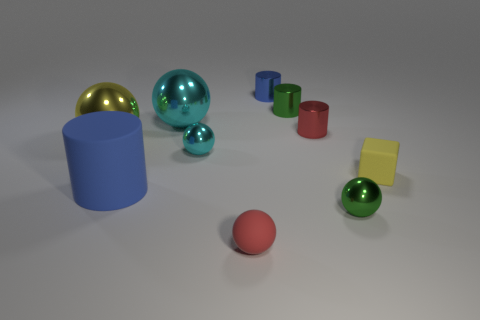The cyan thing that is left of the small cyan ball that is in front of the tiny blue metallic object is what shape?
Your response must be concise. Sphere. What number of green objects are either cubes or rubber objects?
Your response must be concise. 0. Are there any tiny blue metal objects in front of the tiny rubber thing behind the cylinder that is in front of the yellow metallic thing?
Offer a very short reply. No. What is the shape of the metal thing that is the same color as the big matte object?
Make the answer very short. Cylinder. Is there any other thing that is made of the same material as the large yellow ball?
Provide a short and direct response. Yes. How many tiny objects are either yellow shiny cylinders or matte cubes?
Keep it short and to the point. 1. There is a large blue object that is left of the red cylinder; is its shape the same as the yellow shiny thing?
Your answer should be compact. No. Is the number of cyan balls less than the number of small blue metallic objects?
Offer a terse response. No. Is there any other thing that has the same color as the large rubber thing?
Your response must be concise. Yes. There is a green object behind the large cylinder; what is its shape?
Offer a terse response. Cylinder. 